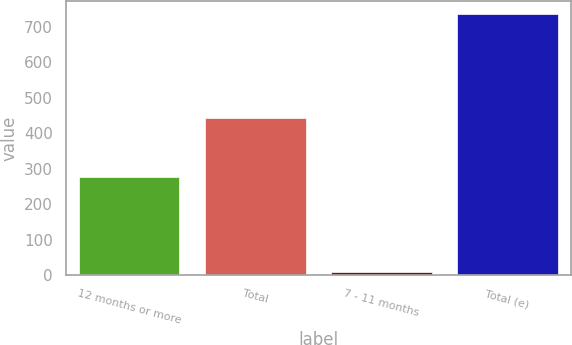Convert chart. <chart><loc_0><loc_0><loc_500><loc_500><bar_chart><fcel>12 months or more<fcel>Total<fcel>7 - 11 months<fcel>Total (e)<nl><fcel>277<fcel>444<fcel>9<fcel>736<nl></chart> 